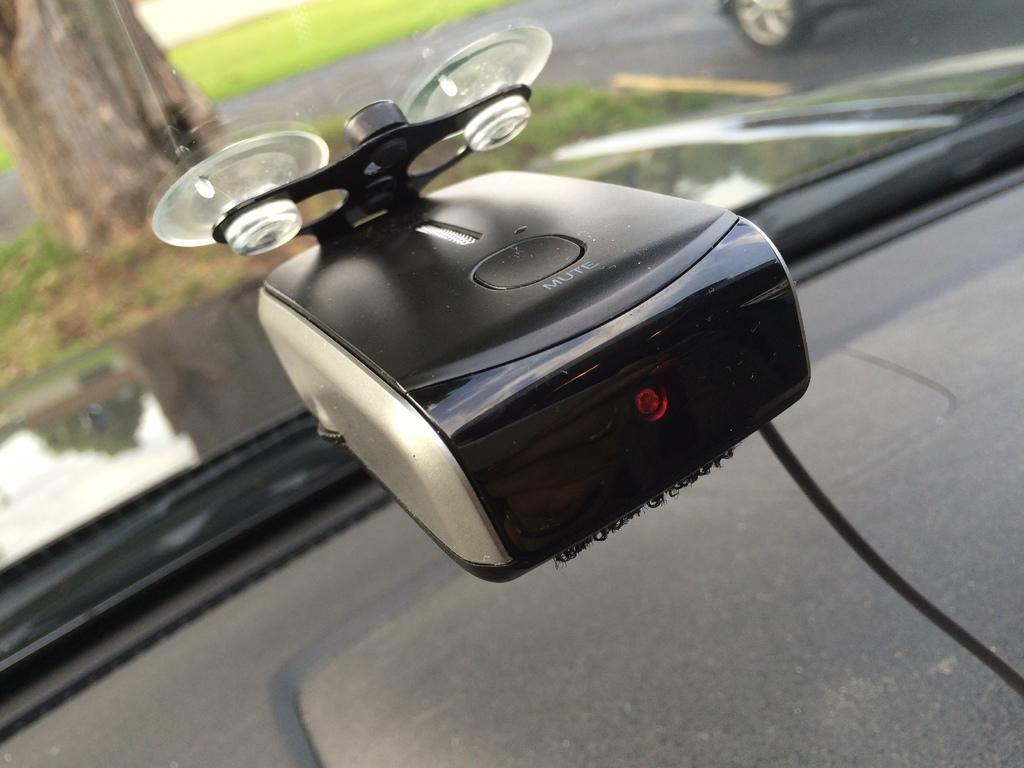Describe this image in one or two sentences. In this image in the center it might be a device, at the bottom there is a vehicle and in the background there are some vehicles, grass and trees. 